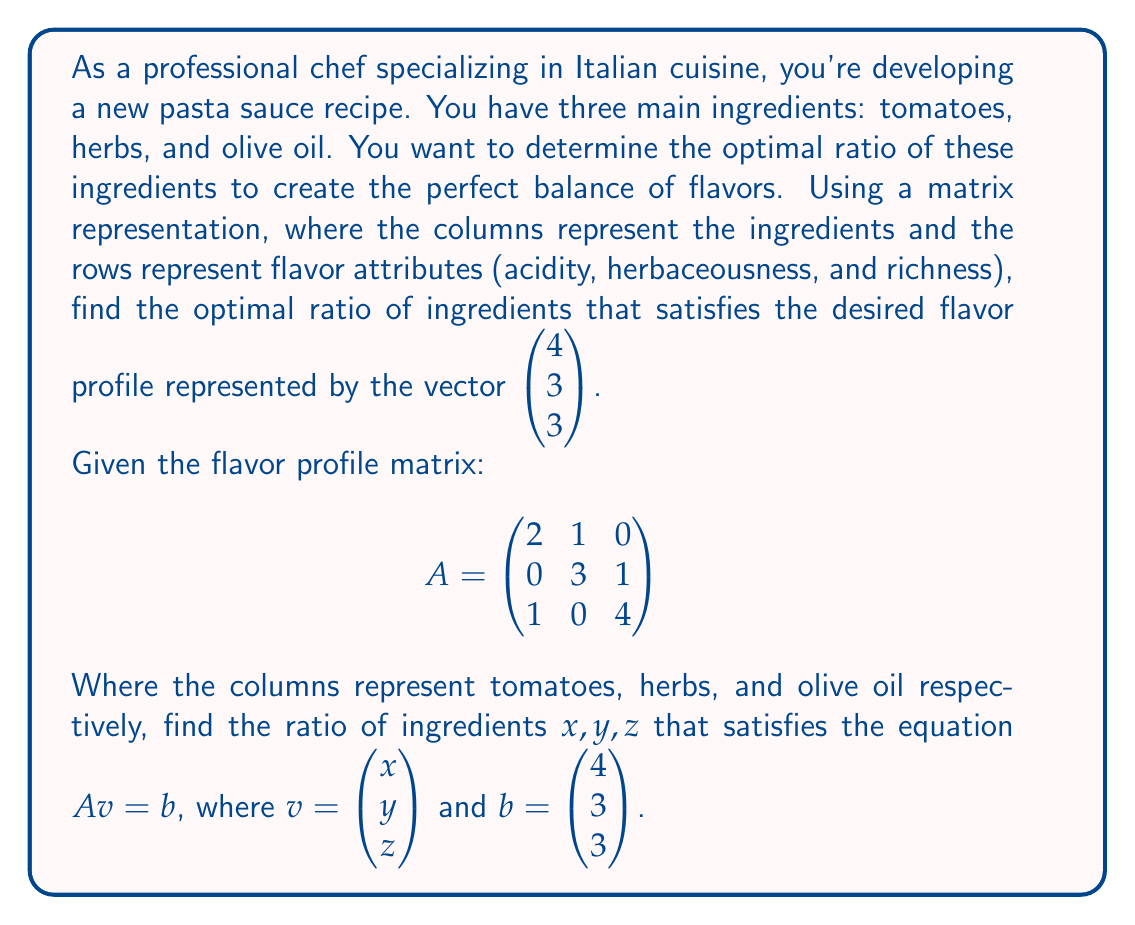Teach me how to tackle this problem. To solve this problem, we need to use linear algebra techniques, specifically solving a system of linear equations using matrix operations.

1) We start with the equation $Av = b$, where:

   $$A = \begin{pmatrix}
   2 & 1 & 0 \\
   0 & 3 & 1 \\
   1 & 0 & 4
   \end{pmatrix}$$

   $$v = \begin{pmatrix} x \\ y \\ z \end{pmatrix}$$

   $$b = \begin{pmatrix} 4 \\ 3 \\ 3 \end{pmatrix}$$

2) To solve for v, we need to multiply both sides by the inverse of A:

   $A^{-1}Av = A^{-1}b$
   $v = A^{-1}b$

3) Let's calculate $A^{-1}$:

   $$A^{-1} = \frac{1}{det(A)} \cdot adj(A)$$

   $det(A) = 2(12) - 1(0) + 0(3) = 24$

   $$adj(A) = \begin{pmatrix}
   12 & -1 & -3 \\
   -4 & 8 & -1 \\
   1 & -3 & 6
   \end{pmatrix}$$

   $$A^{-1} = \frac{1}{24} \begin{pmatrix}
   12 & -1 & -3 \\
   -4 & 8 & -1 \\
   1 & -3 & 6
   \end{pmatrix}$$

4) Now we can calculate v:

   $$v = A^{-1}b = \frac{1}{24} \begin{pmatrix}
   12 & -1 & -3 \\
   -4 & 8 & -1 \\
   1 & -3 & 6
   \end{pmatrix} \begin{pmatrix} 4 \\ 3 \\ 3 \end{pmatrix}$$

   $$v = \frac{1}{24} \begin{pmatrix}
   12(4) + (-1)(3) + (-3)(3) \\
   (-4)(4) + 8(3) + (-1)(3) \\
   1(4) + (-3)(3) + 6(3)
   \end{pmatrix}$$

   $$v = \frac{1}{24} \begin{pmatrix} 36 \\ 12 \\ 13 \end{pmatrix}$$

   $$v = \begin{pmatrix} 1.5 \\ 0.5 \\ 0.54167 \end{pmatrix}$$

5) To express this as a ratio, we can divide each component by the smallest value (0.5):

   $$\frac{v}{0.5} = \begin{pmatrix} 3 \\ 1 \\ 1.0833 \end{pmatrix}$$

Therefore, the optimal ratio of tomatoes : herbs : olive oil is approximately 3 : 1 : 1.
Answer: The optimal ratio of ingredients (tomatoes : herbs : olive oil) is approximately 3 : 1 : 1. 